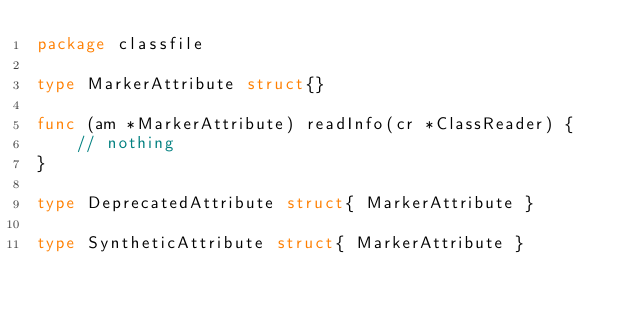<code> <loc_0><loc_0><loc_500><loc_500><_Go_>package classfile

type MarkerAttribute struct{}

func (am *MarkerAttribute) readInfo(cr *ClassReader) {
	// nothing
}

type DeprecatedAttribute struct{ MarkerAttribute }

type SyntheticAttribute struct{ MarkerAttribute }
</code> 